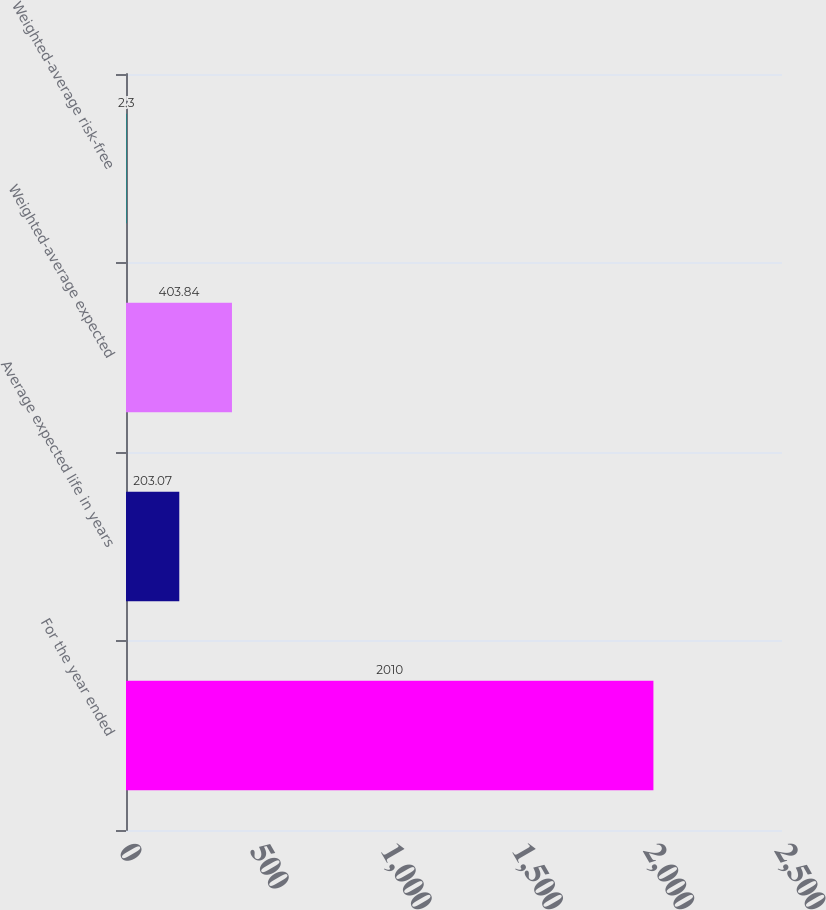Convert chart to OTSL. <chart><loc_0><loc_0><loc_500><loc_500><bar_chart><fcel>For the year ended<fcel>Average expected life in years<fcel>Weighted-average expected<fcel>Weighted-average risk-free<nl><fcel>2010<fcel>203.07<fcel>403.84<fcel>2.3<nl></chart> 